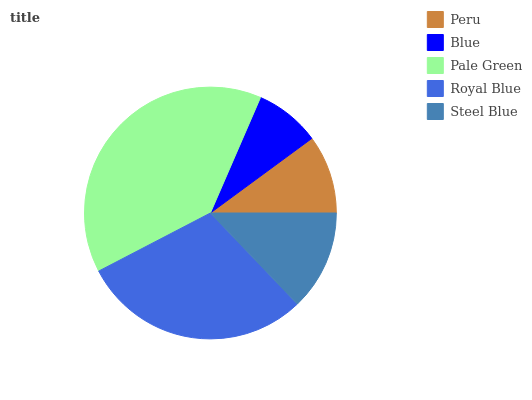Is Blue the minimum?
Answer yes or no. Yes. Is Pale Green the maximum?
Answer yes or no. Yes. Is Pale Green the minimum?
Answer yes or no. No. Is Blue the maximum?
Answer yes or no. No. Is Pale Green greater than Blue?
Answer yes or no. Yes. Is Blue less than Pale Green?
Answer yes or no. Yes. Is Blue greater than Pale Green?
Answer yes or no. No. Is Pale Green less than Blue?
Answer yes or no. No. Is Steel Blue the high median?
Answer yes or no. Yes. Is Steel Blue the low median?
Answer yes or no. Yes. Is Blue the high median?
Answer yes or no. No. Is Pale Green the low median?
Answer yes or no. No. 